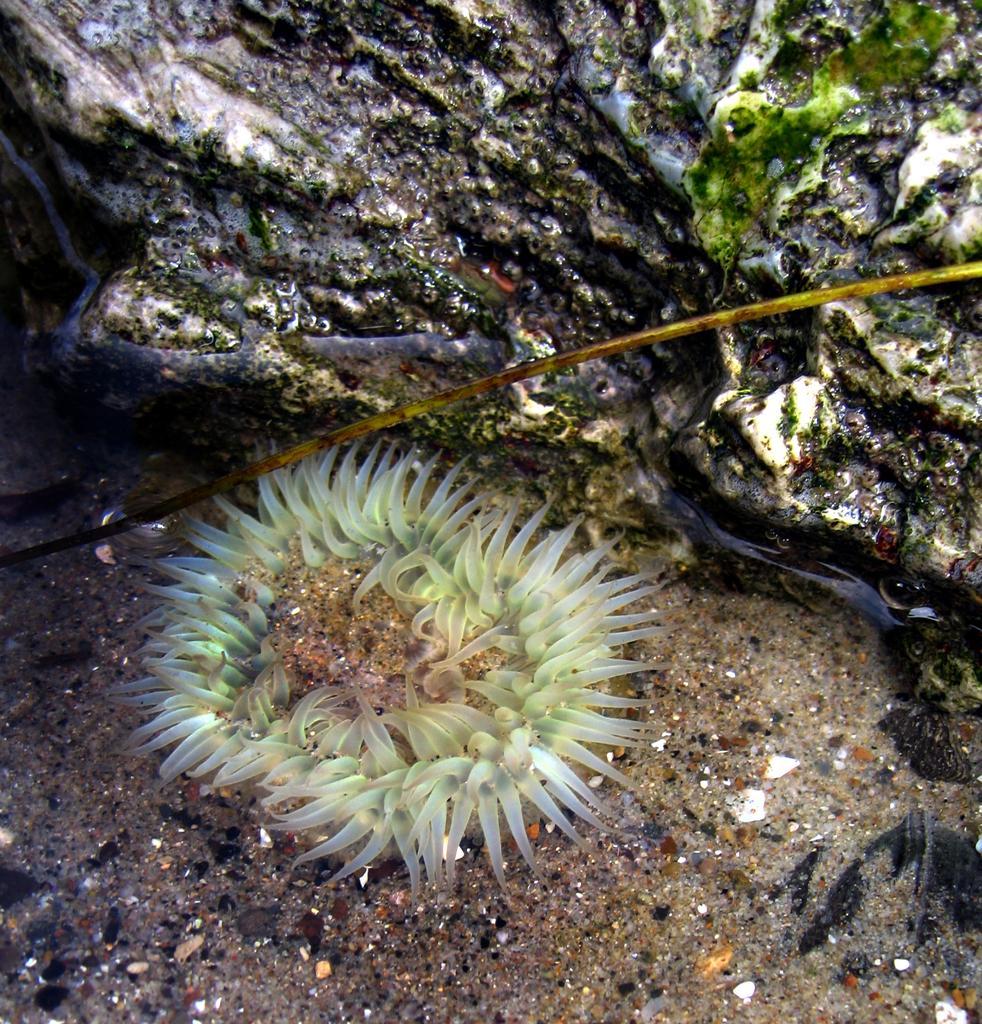Could you give a brief overview of what you see in this image? In this image, we can see the chlorophyta. We can also see the ground and some algae. 